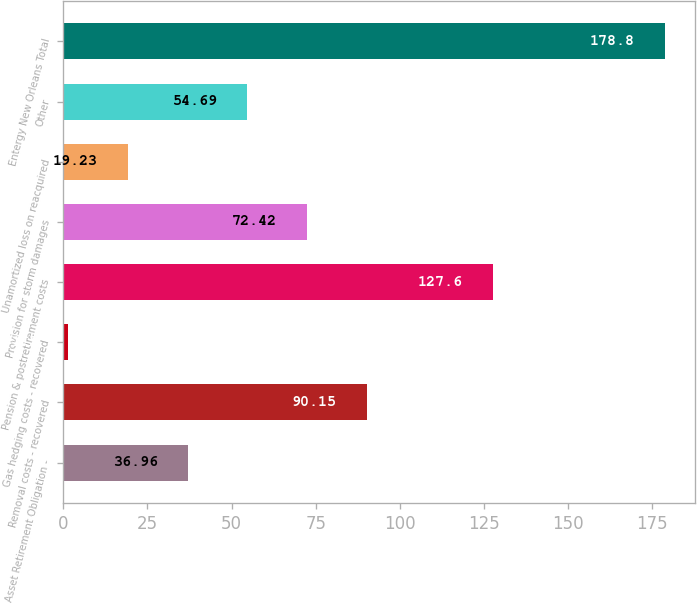<chart> <loc_0><loc_0><loc_500><loc_500><bar_chart><fcel>Asset Retirement Obligation -<fcel>Removal costs - recovered<fcel>Gas hedging costs - recovered<fcel>Pension & postretirement costs<fcel>Provision for storm damages<fcel>Unamortized loss on reacquired<fcel>Other<fcel>Entergy New Orleans Total<nl><fcel>36.96<fcel>90.15<fcel>1.5<fcel>127.6<fcel>72.42<fcel>19.23<fcel>54.69<fcel>178.8<nl></chart> 